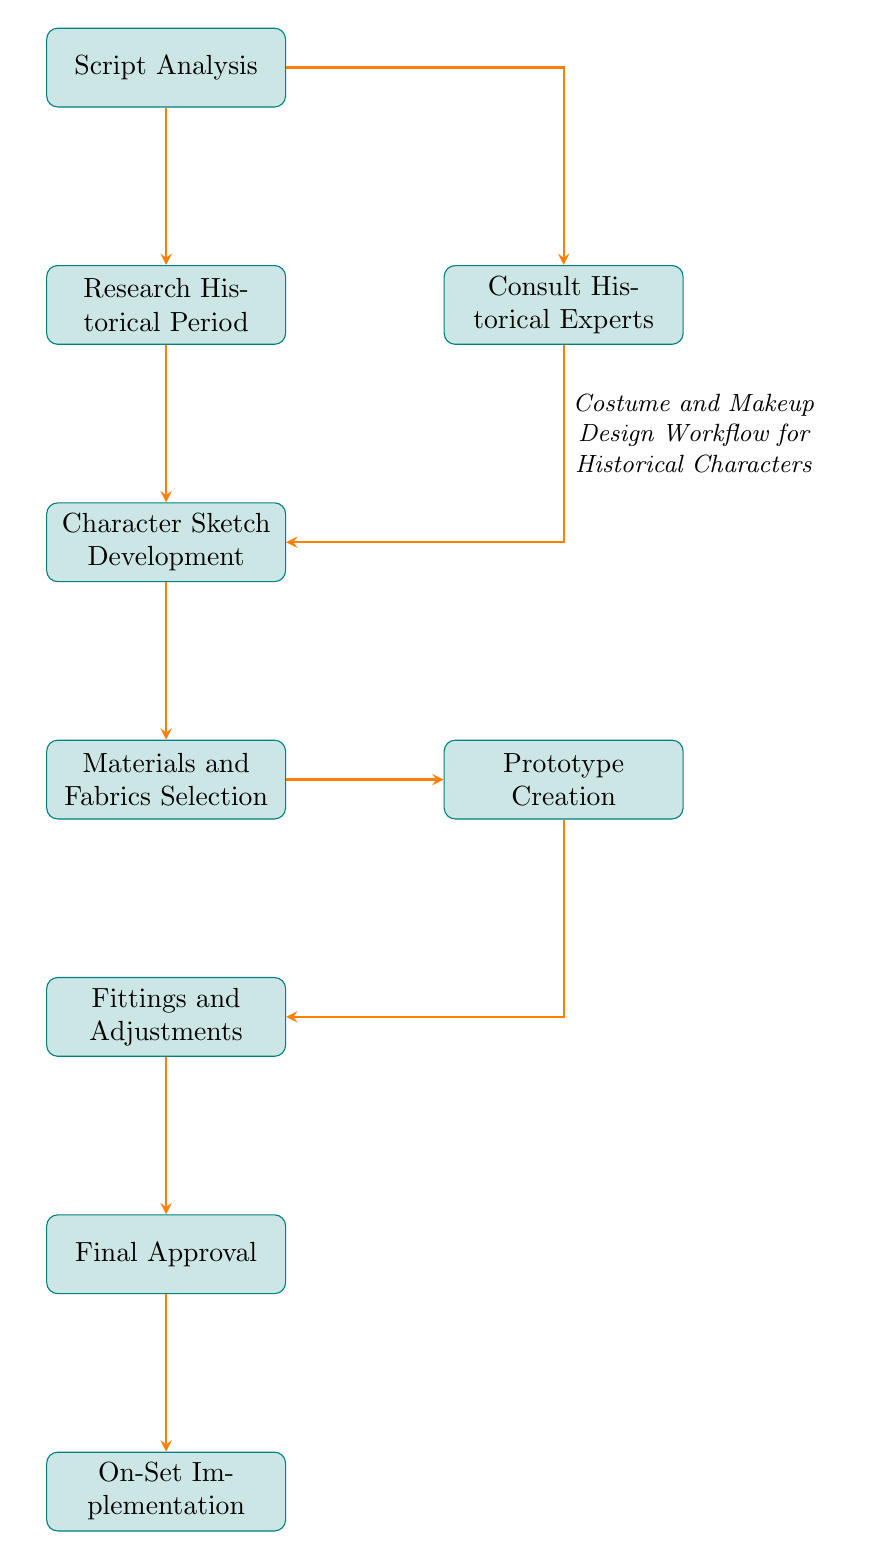What is the first step in the workflow? The diagram shows that the first step, or starting point, in the workflow is "Script Analysis." This is typically the initial phase in many workflows, where the script is reviewed for important details.
Answer: Script Analysis How many nodes are in the diagram? By counting each rectangle in the diagram, we find that there are a total of 9 nodes that represent various steps in the costume and makeup design workflow.
Answer: 9 Which step comes after "Materials and Fabrics Selection"? The flow chart indicates that after "Materials and Fabrics Selection," the next step is "Prototype Creation." This follows directly in the sequence of steps leading to the finalization of the design.
Answer: Prototype Creation Is "Consult Historical Experts" directly connected to "Final Approval"? The flow chart outlines the flow of steps, and we see that "Consult Historical Experts" is not directly connected to "Final Approval." The connection exists through the steps that follow "Character Sketch Development."
Answer: No What are the two branches that emerge from "Script Analysis"? After "Script Analysis," the diagram shows that there are two branches: one goes to "Research Historical Period" and the second one diverges to "Consult Historical Experts." These branches indicate a parallel process stemming from the initial step.
Answer: Research Historical Period and Consult Historical Experts What is the last step in the workflow? The final node in the workflow, as indicated at the bottom of the flow chart, is "On-Set Implementation." This signifies the conclusion of the design process with practical application during production.
Answer: On-Set Implementation How many steps require fittings? In examining the flow chart, it is clear that "Fittings and Adjustments" is the only step that involves fittings. The sequence indicates it is a standalone process that comes after the prototype creation.
Answer: 1 What describes the role of "Character Sketch Development"? The function of "Character Sketch Development" is to create initial sketches for costumes and makeup, acting as a creative phase that follows research into historical context and expert consultation. This is reflected in the diagram’s text.
Answer: Create initial sketches for costumes and makeup In what sequence do "Fittings and Adjustments" and "Final Approval" occur? According to the diagram, "Fittings and Adjustments" directly precedes "Final Approval." This indicates that fittings occur first, followed by obtaining approval before moving on to the final implementation stage.
Answer: Fittings and Adjustments, then Final Approval 